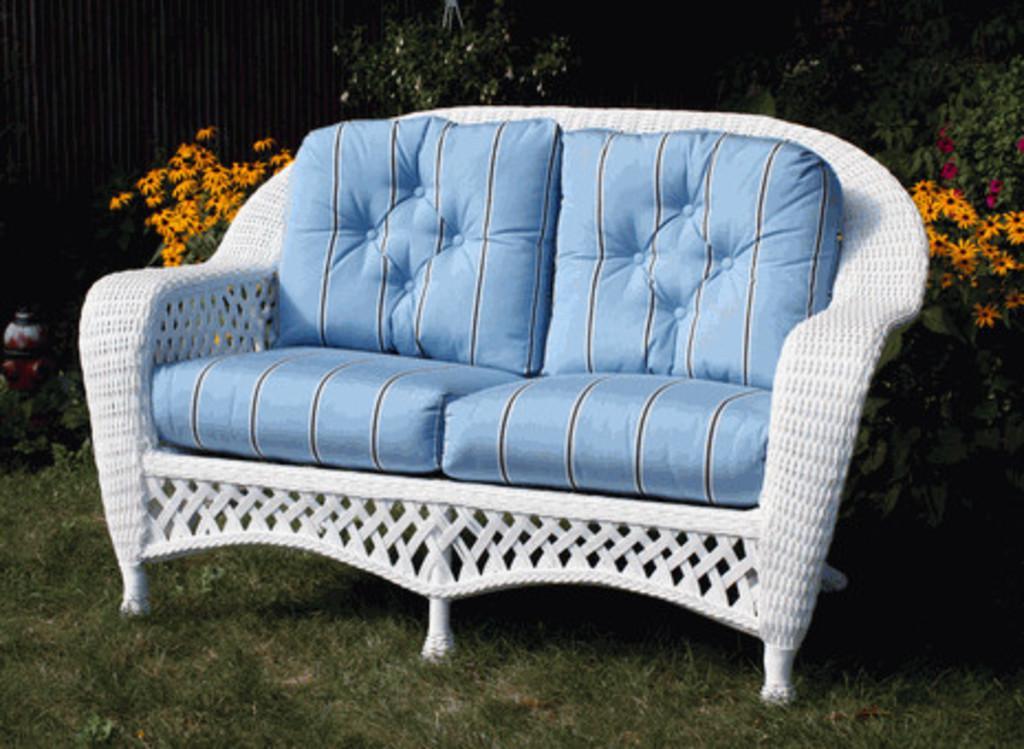How would you summarize this image in a sentence or two? In this image I can see a couch which is blue, black and white in color on the ground. I can see some grass, few plants to which I can see few flowers which are orange and pink in color. In the background I can see few trees and the wall. 